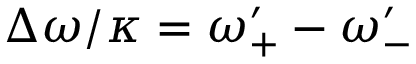<formula> <loc_0><loc_0><loc_500><loc_500>\Delta \omega / \kappa = \omega _ { + } ^ { \prime } - \omega _ { - } ^ { \prime }</formula> 